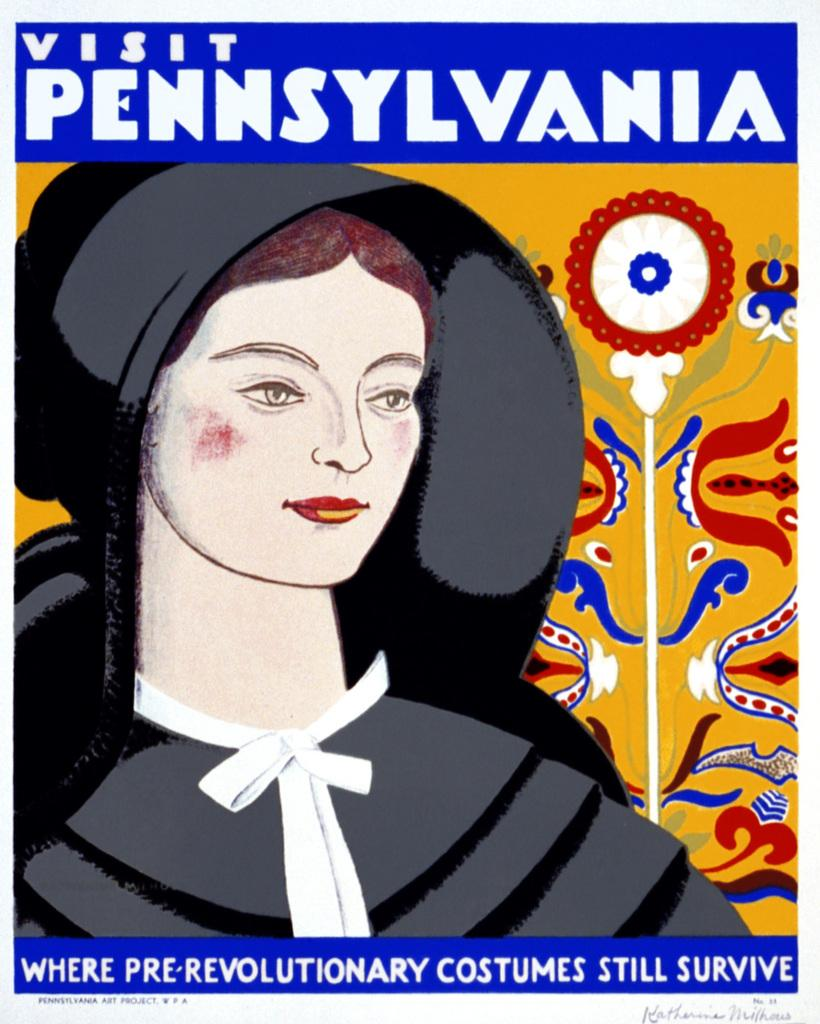What is the main subject of the poster in the image? The poster depicts a woman. Where is the text located on the poster? There is text at the top and bottom of the image. Can you see any soap bubbles floating around the woman in the poster? There are no soap bubbles present in the image; the poster depicts a woman without any bubbles or other objects. 